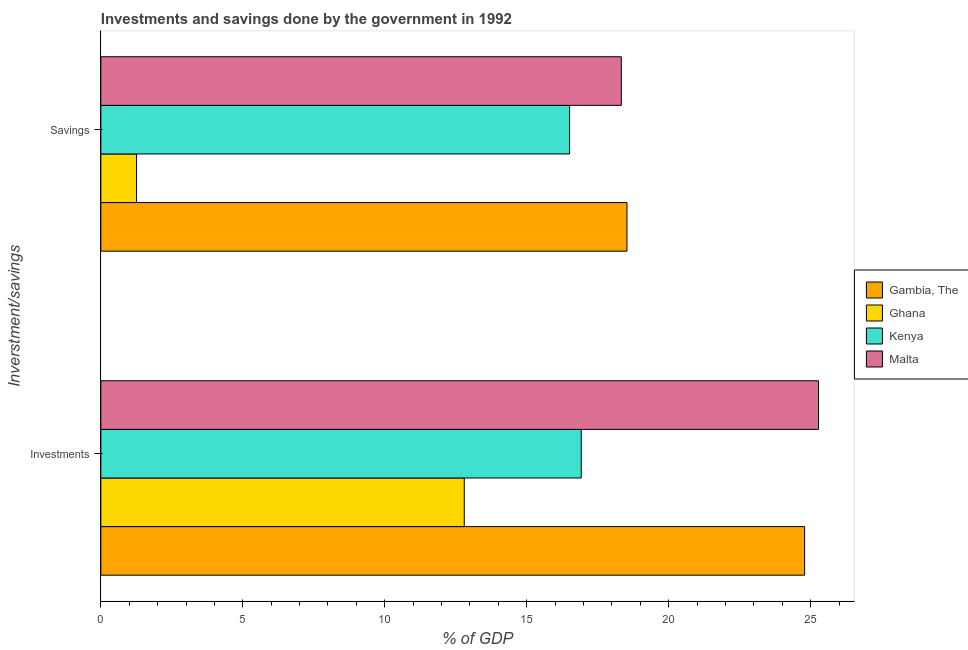How many different coloured bars are there?
Provide a succinct answer. 4. Are the number of bars per tick equal to the number of legend labels?
Provide a succinct answer. Yes. What is the label of the 1st group of bars from the top?
Offer a terse response. Savings. What is the investments of government in Malta?
Ensure brevity in your answer.  25.28. Across all countries, what is the maximum investments of government?
Keep it short and to the point. 25.28. In which country was the savings of government maximum?
Offer a terse response. Gambia, The. What is the total investments of government in the graph?
Give a very brief answer. 79.79. What is the difference between the savings of government in Gambia, The and that in Kenya?
Your response must be concise. 2.02. What is the difference between the investments of government in Gambia, The and the savings of government in Kenya?
Your answer should be very brief. 8.28. What is the average investments of government per country?
Make the answer very short. 19.95. What is the difference between the investments of government and savings of government in Gambia, The?
Your response must be concise. 6.26. In how many countries, is the savings of government greater than 24 %?
Your answer should be compact. 0. What is the ratio of the savings of government in Ghana to that in Gambia, The?
Give a very brief answer. 0.07. In how many countries, is the savings of government greater than the average savings of government taken over all countries?
Provide a succinct answer. 3. What does the 1st bar from the top in Investments represents?
Keep it short and to the point. Malta. What does the 2nd bar from the bottom in Investments represents?
Offer a very short reply. Ghana. How many bars are there?
Provide a short and direct response. 8. Are all the bars in the graph horizontal?
Make the answer very short. Yes. What is the difference between two consecutive major ticks on the X-axis?
Offer a terse response. 5. Are the values on the major ticks of X-axis written in scientific E-notation?
Provide a short and direct response. No. Does the graph contain any zero values?
Your answer should be compact. No. Where does the legend appear in the graph?
Provide a short and direct response. Center right. How many legend labels are there?
Your answer should be very brief. 4. What is the title of the graph?
Offer a very short reply. Investments and savings done by the government in 1992. What is the label or title of the X-axis?
Keep it short and to the point. % of GDP. What is the label or title of the Y-axis?
Ensure brevity in your answer.  Inverstment/savings. What is the % of GDP of Gambia, The in Investments?
Provide a short and direct response. 24.79. What is the % of GDP of Ghana in Investments?
Your answer should be compact. 12.8. What is the % of GDP in Kenya in Investments?
Your response must be concise. 16.92. What is the % of GDP in Malta in Investments?
Provide a succinct answer. 25.28. What is the % of GDP of Gambia, The in Savings?
Your answer should be compact. 18.53. What is the % of GDP in Ghana in Savings?
Keep it short and to the point. 1.26. What is the % of GDP of Kenya in Savings?
Make the answer very short. 16.51. What is the % of GDP in Malta in Savings?
Give a very brief answer. 18.33. Across all Inverstment/savings, what is the maximum % of GDP in Gambia, The?
Your answer should be very brief. 24.79. Across all Inverstment/savings, what is the maximum % of GDP of Kenya?
Provide a succinct answer. 16.92. Across all Inverstment/savings, what is the maximum % of GDP in Malta?
Make the answer very short. 25.28. Across all Inverstment/savings, what is the minimum % of GDP in Gambia, The?
Your answer should be very brief. 18.53. Across all Inverstment/savings, what is the minimum % of GDP of Ghana?
Your response must be concise. 1.26. Across all Inverstment/savings, what is the minimum % of GDP in Kenya?
Offer a very short reply. 16.51. Across all Inverstment/savings, what is the minimum % of GDP in Malta?
Your response must be concise. 18.33. What is the total % of GDP of Gambia, The in the graph?
Offer a terse response. 43.32. What is the total % of GDP of Ghana in the graph?
Make the answer very short. 14.06. What is the total % of GDP of Kenya in the graph?
Offer a very short reply. 33.43. What is the total % of GDP in Malta in the graph?
Provide a succinct answer. 43.61. What is the difference between the % of GDP in Gambia, The in Investments and that in Savings?
Keep it short and to the point. 6.26. What is the difference between the % of GDP of Ghana in Investments and that in Savings?
Provide a short and direct response. 11.54. What is the difference between the % of GDP in Kenya in Investments and that in Savings?
Make the answer very short. 0.41. What is the difference between the % of GDP in Malta in Investments and that in Savings?
Ensure brevity in your answer.  6.95. What is the difference between the % of GDP of Gambia, The in Investments and the % of GDP of Ghana in Savings?
Offer a terse response. 23.53. What is the difference between the % of GDP of Gambia, The in Investments and the % of GDP of Kenya in Savings?
Keep it short and to the point. 8.28. What is the difference between the % of GDP in Gambia, The in Investments and the % of GDP in Malta in Savings?
Make the answer very short. 6.46. What is the difference between the % of GDP of Ghana in Investments and the % of GDP of Kenya in Savings?
Your response must be concise. -3.71. What is the difference between the % of GDP of Ghana in Investments and the % of GDP of Malta in Savings?
Make the answer very short. -5.53. What is the difference between the % of GDP in Kenya in Investments and the % of GDP in Malta in Savings?
Give a very brief answer. -1.41. What is the average % of GDP of Gambia, The per Inverstment/savings?
Your response must be concise. 21.66. What is the average % of GDP of Ghana per Inverstment/savings?
Your answer should be compact. 7.03. What is the average % of GDP of Kenya per Inverstment/savings?
Offer a terse response. 16.72. What is the average % of GDP in Malta per Inverstment/savings?
Offer a terse response. 21.8. What is the difference between the % of GDP of Gambia, The and % of GDP of Ghana in Investments?
Offer a very short reply. 11.99. What is the difference between the % of GDP in Gambia, The and % of GDP in Kenya in Investments?
Keep it short and to the point. 7.87. What is the difference between the % of GDP of Gambia, The and % of GDP of Malta in Investments?
Your response must be concise. -0.49. What is the difference between the % of GDP of Ghana and % of GDP of Kenya in Investments?
Your answer should be compact. -4.12. What is the difference between the % of GDP in Ghana and % of GDP in Malta in Investments?
Provide a succinct answer. -12.48. What is the difference between the % of GDP of Kenya and % of GDP of Malta in Investments?
Your response must be concise. -8.36. What is the difference between the % of GDP of Gambia, The and % of GDP of Ghana in Savings?
Keep it short and to the point. 17.27. What is the difference between the % of GDP of Gambia, The and % of GDP of Kenya in Savings?
Keep it short and to the point. 2.02. What is the difference between the % of GDP of Gambia, The and % of GDP of Malta in Savings?
Keep it short and to the point. 0.2. What is the difference between the % of GDP in Ghana and % of GDP in Kenya in Savings?
Your answer should be compact. -15.25. What is the difference between the % of GDP in Ghana and % of GDP in Malta in Savings?
Keep it short and to the point. -17.07. What is the difference between the % of GDP in Kenya and % of GDP in Malta in Savings?
Keep it short and to the point. -1.82. What is the ratio of the % of GDP of Gambia, The in Investments to that in Savings?
Your answer should be very brief. 1.34. What is the ratio of the % of GDP of Ghana in Investments to that in Savings?
Your response must be concise. 10.17. What is the ratio of the % of GDP of Kenya in Investments to that in Savings?
Ensure brevity in your answer.  1.02. What is the ratio of the % of GDP of Malta in Investments to that in Savings?
Offer a very short reply. 1.38. What is the difference between the highest and the second highest % of GDP in Gambia, The?
Your response must be concise. 6.26. What is the difference between the highest and the second highest % of GDP in Ghana?
Your answer should be compact. 11.54. What is the difference between the highest and the second highest % of GDP in Kenya?
Keep it short and to the point. 0.41. What is the difference between the highest and the second highest % of GDP in Malta?
Make the answer very short. 6.95. What is the difference between the highest and the lowest % of GDP in Gambia, The?
Offer a terse response. 6.26. What is the difference between the highest and the lowest % of GDP in Ghana?
Provide a succinct answer. 11.54. What is the difference between the highest and the lowest % of GDP in Kenya?
Your answer should be very brief. 0.41. What is the difference between the highest and the lowest % of GDP of Malta?
Your response must be concise. 6.95. 